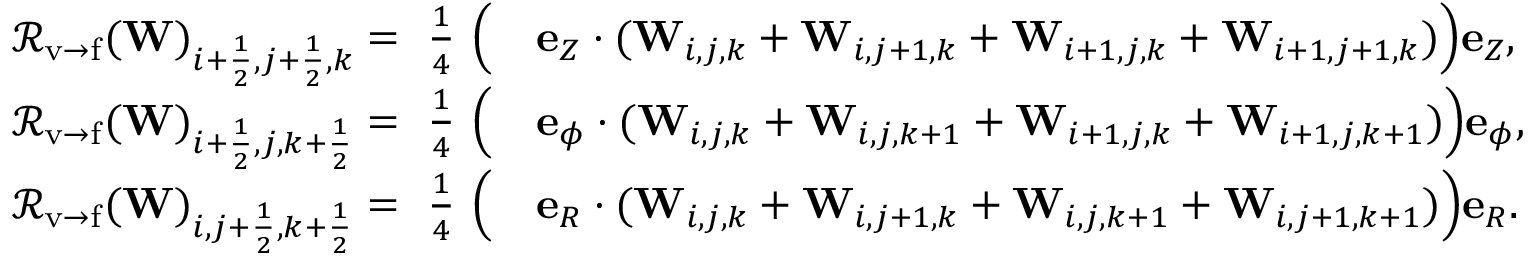Convert formula to latex. <formula><loc_0><loc_0><loc_500><loc_500>\begin{array} { r l } { { \mathcal { R } } _ { v \rightarrow f } ( W ) _ { i + \frac { 1 } { 2 } , j + \frac { 1 } { 2 } , k } = \frac { 1 } { 4 } { \left ( } } & { e _ { Z } \cdot ( W _ { i , j , k } + W _ { i , j + 1 , k } + W _ { i + 1 , j , k } + W _ { i + 1 , j + 1 , k } ) { \right ) } e _ { Z } , } \\ { { \mathcal { R } } _ { v \rightarrow f } ( W ) _ { i + \frac { 1 } { 2 } , j , k + \frac { 1 } { 2 } } = \frac { 1 } { 4 } { \left ( } } & { e _ { \phi } \cdot ( W _ { i , j , k } + W _ { i , j , k + 1 } + W _ { i + 1 , j , k } + W _ { i + 1 , j , k + 1 } ) { \right ) } e _ { \phi } , } \\ { { \mathcal { R } } _ { v \rightarrow f } ( W ) _ { i , j + \frac { 1 } { 2 } , k + \frac { 1 } { 2 } } = \frac { 1 } { 4 } { \left ( } } & { e _ { R } \cdot ( W _ { i , j , k } + W _ { i , j + 1 , k } + W _ { i , j , k + 1 } + W _ { i , j + 1 , k + 1 } ) { \right ) } e _ { R } . } \end{array}</formula> 